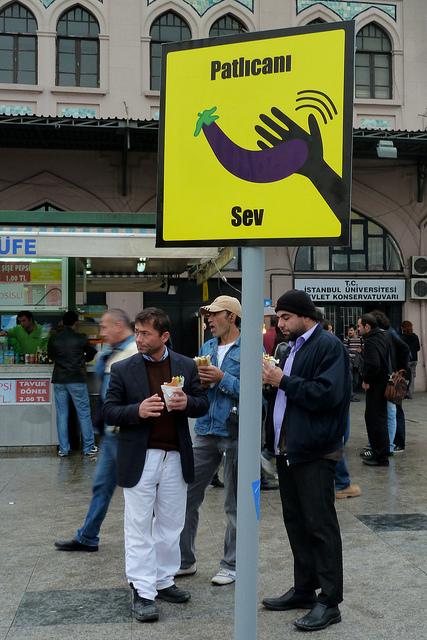What color stands out?
Answer briefly. Yellow. Where are the men behind the yellow sign on a gray pole?
Answer briefly. City. What body part is depicted in the sign?
Be succinct. Hand. What profession are the men in the picture?
Short answer required. Business. What type of food does the restaurant serve?
Quick response, please. Eggplant. 